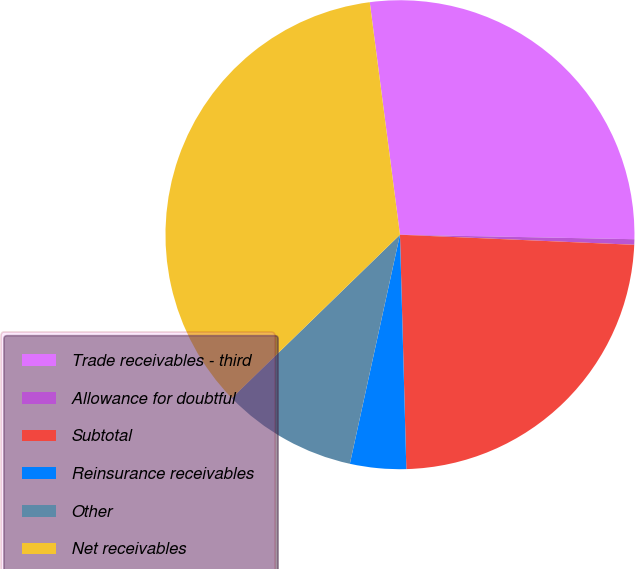Convert chart to OTSL. <chart><loc_0><loc_0><loc_500><loc_500><pie_chart><fcel>Trade receivables - third<fcel>Allowance for doubtful<fcel>Subtotal<fcel>Reinsurance receivables<fcel>Other<fcel>Net receivables<nl><fcel>27.36%<fcel>0.38%<fcel>23.88%<fcel>3.86%<fcel>9.3%<fcel>35.21%<nl></chart> 